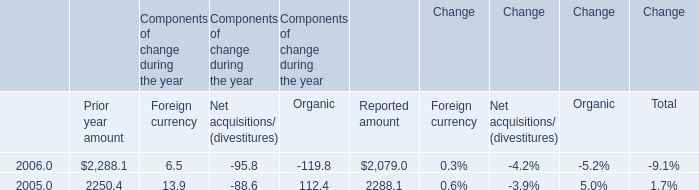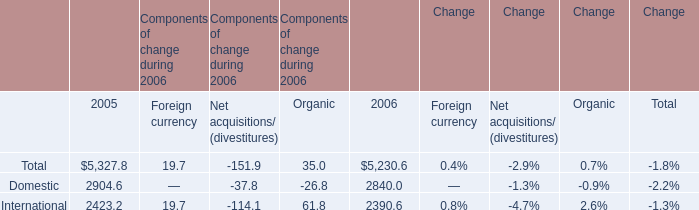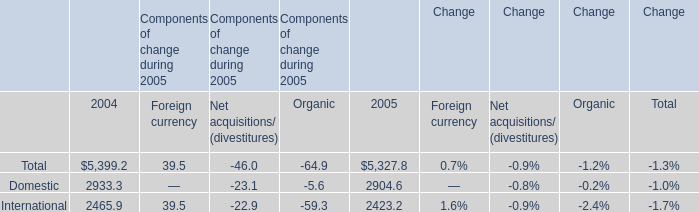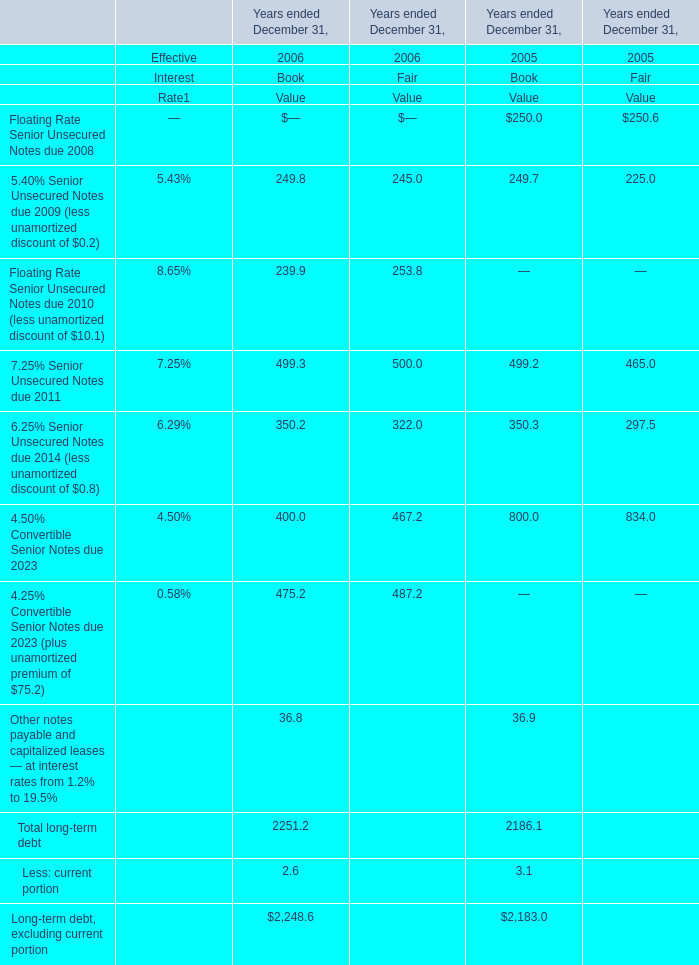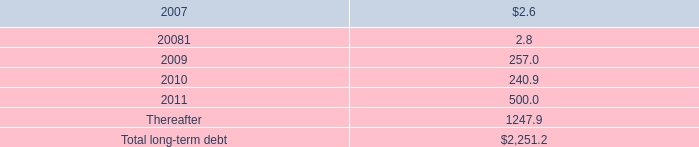What's the increasing rate of the Book Value of the long-term debt, excluding current portion in 2006? 
Computations: ((2248.6 - 2183) / 2183)
Answer: 0.03005. 